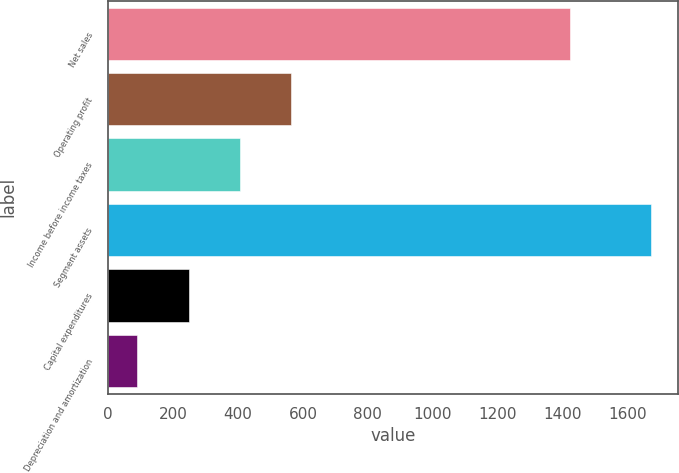<chart> <loc_0><loc_0><loc_500><loc_500><bar_chart><fcel>Net sales<fcel>Operating profit<fcel>Income before income taxes<fcel>Segment assets<fcel>Capital expenditures<fcel>Depreciation and amortization<nl><fcel>1421.4<fcel>564.27<fcel>406.18<fcel>1670.9<fcel>248.09<fcel>90<nl></chart> 